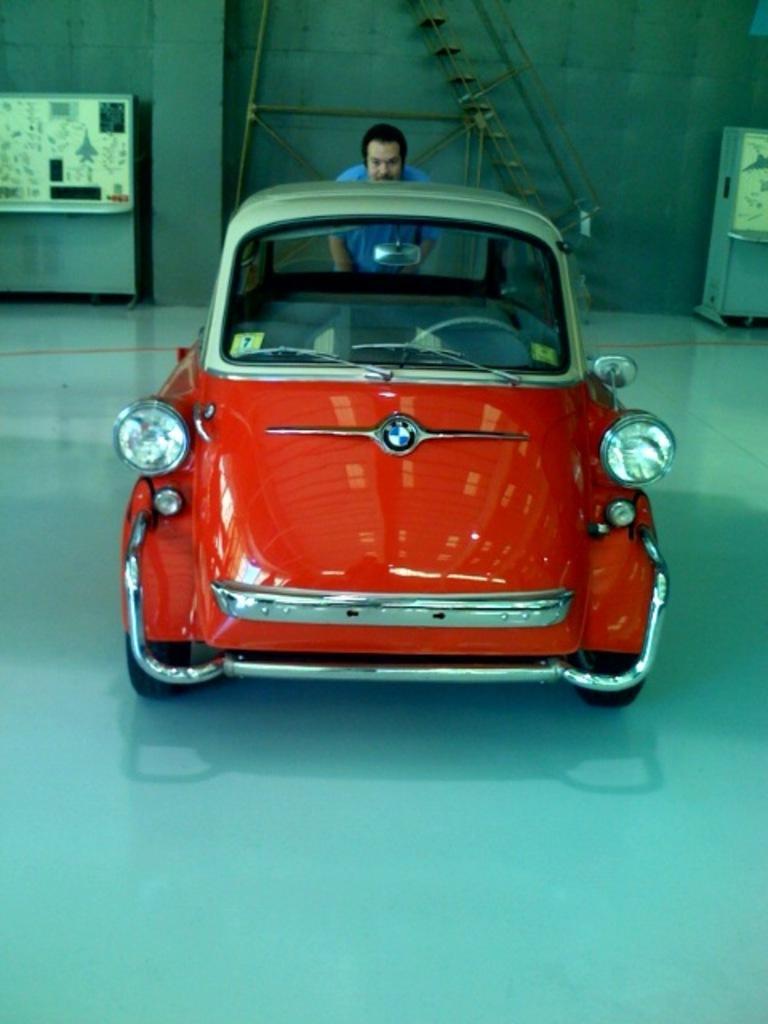Can you describe this image briefly? This image consists of a car in red color behind which there is a man standing. At the bottom, there is a floor. In the background, we can see a ladder. On the left and right, there are machines. 